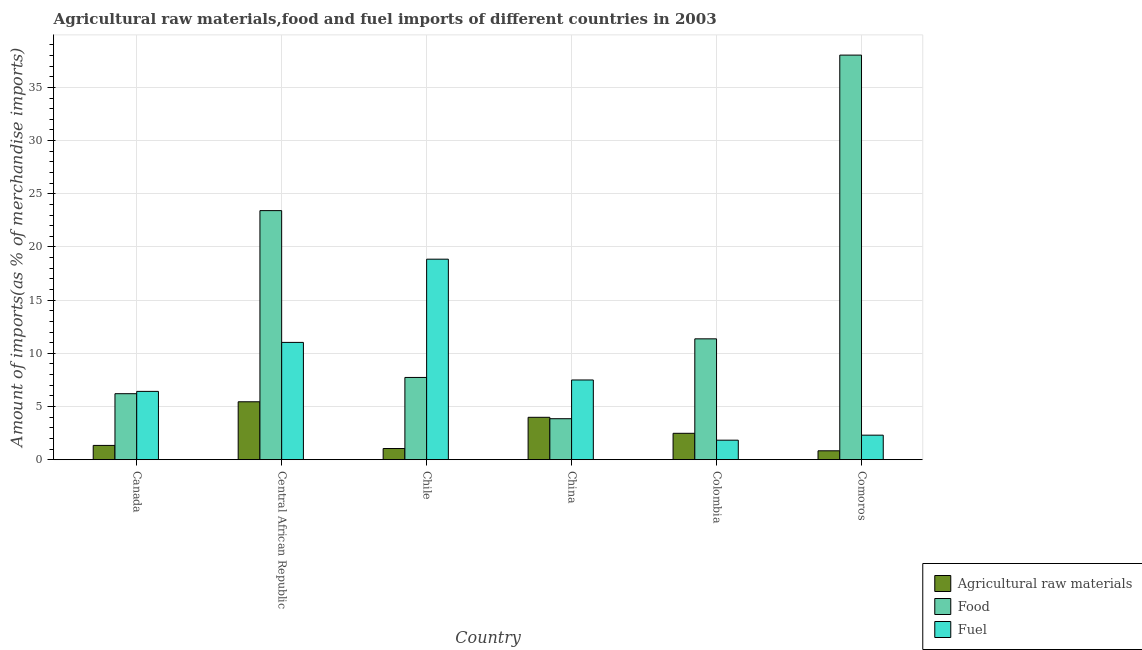How many groups of bars are there?
Your answer should be compact. 6. How many bars are there on the 6th tick from the left?
Your answer should be very brief. 3. How many bars are there on the 2nd tick from the right?
Ensure brevity in your answer.  3. In how many cases, is the number of bars for a given country not equal to the number of legend labels?
Your answer should be very brief. 0. What is the percentage of food imports in China?
Keep it short and to the point. 3.85. Across all countries, what is the maximum percentage of raw materials imports?
Give a very brief answer. 5.45. Across all countries, what is the minimum percentage of raw materials imports?
Provide a short and direct response. 0.84. In which country was the percentage of raw materials imports maximum?
Provide a succinct answer. Central African Republic. In which country was the percentage of fuel imports minimum?
Your response must be concise. Colombia. What is the total percentage of raw materials imports in the graph?
Your answer should be compact. 15.14. What is the difference between the percentage of fuel imports in Central African Republic and that in China?
Keep it short and to the point. 3.53. What is the difference between the percentage of raw materials imports in Chile and the percentage of food imports in Central African Republic?
Provide a short and direct response. -22.37. What is the average percentage of raw materials imports per country?
Your answer should be very brief. 2.52. What is the difference between the percentage of food imports and percentage of raw materials imports in China?
Offer a very short reply. -0.13. In how many countries, is the percentage of raw materials imports greater than 36 %?
Ensure brevity in your answer.  0. What is the ratio of the percentage of raw materials imports in Canada to that in Comoros?
Your response must be concise. 1.61. What is the difference between the highest and the second highest percentage of food imports?
Give a very brief answer. 14.62. What is the difference between the highest and the lowest percentage of food imports?
Your response must be concise. 34.19. In how many countries, is the percentage of raw materials imports greater than the average percentage of raw materials imports taken over all countries?
Make the answer very short. 2. What does the 3rd bar from the left in Colombia represents?
Your response must be concise. Fuel. What does the 1st bar from the right in Central African Republic represents?
Your answer should be very brief. Fuel. Is it the case that in every country, the sum of the percentage of raw materials imports and percentage of food imports is greater than the percentage of fuel imports?
Your response must be concise. No. How many countries are there in the graph?
Your answer should be very brief. 6. Does the graph contain any zero values?
Your response must be concise. No. Where does the legend appear in the graph?
Your answer should be compact. Bottom right. How many legend labels are there?
Offer a very short reply. 3. How are the legend labels stacked?
Your answer should be very brief. Vertical. What is the title of the graph?
Make the answer very short. Agricultural raw materials,food and fuel imports of different countries in 2003. What is the label or title of the Y-axis?
Your response must be concise. Amount of imports(as % of merchandise imports). What is the Amount of imports(as % of merchandise imports) in Agricultural raw materials in Canada?
Provide a short and direct response. 1.34. What is the Amount of imports(as % of merchandise imports) of Food in Canada?
Give a very brief answer. 6.21. What is the Amount of imports(as % of merchandise imports) in Fuel in Canada?
Your response must be concise. 6.42. What is the Amount of imports(as % of merchandise imports) in Agricultural raw materials in Central African Republic?
Your answer should be compact. 5.45. What is the Amount of imports(as % of merchandise imports) in Food in Central African Republic?
Give a very brief answer. 23.42. What is the Amount of imports(as % of merchandise imports) of Fuel in Central African Republic?
Offer a terse response. 11.03. What is the Amount of imports(as % of merchandise imports) of Agricultural raw materials in Chile?
Provide a succinct answer. 1.05. What is the Amount of imports(as % of merchandise imports) of Food in Chile?
Your answer should be very brief. 7.73. What is the Amount of imports(as % of merchandise imports) of Fuel in Chile?
Make the answer very short. 18.85. What is the Amount of imports(as % of merchandise imports) of Agricultural raw materials in China?
Your response must be concise. 3.99. What is the Amount of imports(as % of merchandise imports) in Food in China?
Your response must be concise. 3.85. What is the Amount of imports(as % of merchandise imports) of Fuel in China?
Ensure brevity in your answer.  7.5. What is the Amount of imports(as % of merchandise imports) of Agricultural raw materials in Colombia?
Provide a succinct answer. 2.48. What is the Amount of imports(as % of merchandise imports) of Food in Colombia?
Your response must be concise. 11.36. What is the Amount of imports(as % of merchandise imports) of Fuel in Colombia?
Your answer should be compact. 1.83. What is the Amount of imports(as % of merchandise imports) of Agricultural raw materials in Comoros?
Offer a terse response. 0.84. What is the Amount of imports(as % of merchandise imports) in Food in Comoros?
Your answer should be very brief. 38.04. What is the Amount of imports(as % of merchandise imports) in Fuel in Comoros?
Make the answer very short. 2.31. Across all countries, what is the maximum Amount of imports(as % of merchandise imports) in Agricultural raw materials?
Ensure brevity in your answer.  5.45. Across all countries, what is the maximum Amount of imports(as % of merchandise imports) in Food?
Give a very brief answer. 38.04. Across all countries, what is the maximum Amount of imports(as % of merchandise imports) in Fuel?
Keep it short and to the point. 18.85. Across all countries, what is the minimum Amount of imports(as % of merchandise imports) in Agricultural raw materials?
Give a very brief answer. 0.84. Across all countries, what is the minimum Amount of imports(as % of merchandise imports) in Food?
Make the answer very short. 3.85. Across all countries, what is the minimum Amount of imports(as % of merchandise imports) in Fuel?
Give a very brief answer. 1.83. What is the total Amount of imports(as % of merchandise imports) in Agricultural raw materials in the graph?
Offer a very short reply. 15.14. What is the total Amount of imports(as % of merchandise imports) in Food in the graph?
Provide a succinct answer. 90.62. What is the total Amount of imports(as % of merchandise imports) of Fuel in the graph?
Your answer should be compact. 47.94. What is the difference between the Amount of imports(as % of merchandise imports) of Agricultural raw materials in Canada and that in Central African Republic?
Provide a succinct answer. -4.1. What is the difference between the Amount of imports(as % of merchandise imports) of Food in Canada and that in Central African Republic?
Your answer should be compact. -17.21. What is the difference between the Amount of imports(as % of merchandise imports) in Fuel in Canada and that in Central African Republic?
Your answer should be very brief. -4.61. What is the difference between the Amount of imports(as % of merchandise imports) of Agricultural raw materials in Canada and that in Chile?
Offer a very short reply. 0.29. What is the difference between the Amount of imports(as % of merchandise imports) of Food in Canada and that in Chile?
Give a very brief answer. -1.53. What is the difference between the Amount of imports(as % of merchandise imports) in Fuel in Canada and that in Chile?
Offer a terse response. -12.43. What is the difference between the Amount of imports(as % of merchandise imports) of Agricultural raw materials in Canada and that in China?
Keep it short and to the point. -2.64. What is the difference between the Amount of imports(as % of merchandise imports) of Food in Canada and that in China?
Provide a short and direct response. 2.35. What is the difference between the Amount of imports(as % of merchandise imports) of Fuel in Canada and that in China?
Make the answer very short. -1.07. What is the difference between the Amount of imports(as % of merchandise imports) in Agricultural raw materials in Canada and that in Colombia?
Offer a very short reply. -1.14. What is the difference between the Amount of imports(as % of merchandise imports) of Food in Canada and that in Colombia?
Your answer should be compact. -5.16. What is the difference between the Amount of imports(as % of merchandise imports) in Fuel in Canada and that in Colombia?
Keep it short and to the point. 4.59. What is the difference between the Amount of imports(as % of merchandise imports) of Agricultural raw materials in Canada and that in Comoros?
Keep it short and to the point. 0.51. What is the difference between the Amount of imports(as % of merchandise imports) of Food in Canada and that in Comoros?
Give a very brief answer. -31.83. What is the difference between the Amount of imports(as % of merchandise imports) of Fuel in Canada and that in Comoros?
Your answer should be compact. 4.12. What is the difference between the Amount of imports(as % of merchandise imports) of Agricultural raw materials in Central African Republic and that in Chile?
Offer a very short reply. 4.4. What is the difference between the Amount of imports(as % of merchandise imports) in Food in Central African Republic and that in Chile?
Your response must be concise. 15.69. What is the difference between the Amount of imports(as % of merchandise imports) in Fuel in Central African Republic and that in Chile?
Keep it short and to the point. -7.82. What is the difference between the Amount of imports(as % of merchandise imports) in Agricultural raw materials in Central African Republic and that in China?
Provide a succinct answer. 1.46. What is the difference between the Amount of imports(as % of merchandise imports) of Food in Central African Republic and that in China?
Your response must be concise. 19.56. What is the difference between the Amount of imports(as % of merchandise imports) in Fuel in Central African Republic and that in China?
Offer a terse response. 3.53. What is the difference between the Amount of imports(as % of merchandise imports) in Agricultural raw materials in Central African Republic and that in Colombia?
Your answer should be compact. 2.96. What is the difference between the Amount of imports(as % of merchandise imports) in Food in Central African Republic and that in Colombia?
Your answer should be very brief. 12.06. What is the difference between the Amount of imports(as % of merchandise imports) in Fuel in Central African Republic and that in Colombia?
Make the answer very short. 9.19. What is the difference between the Amount of imports(as % of merchandise imports) of Agricultural raw materials in Central African Republic and that in Comoros?
Offer a terse response. 4.61. What is the difference between the Amount of imports(as % of merchandise imports) in Food in Central African Republic and that in Comoros?
Offer a terse response. -14.62. What is the difference between the Amount of imports(as % of merchandise imports) in Fuel in Central African Republic and that in Comoros?
Make the answer very short. 8.72. What is the difference between the Amount of imports(as % of merchandise imports) in Agricultural raw materials in Chile and that in China?
Give a very brief answer. -2.94. What is the difference between the Amount of imports(as % of merchandise imports) of Food in Chile and that in China?
Offer a terse response. 3.88. What is the difference between the Amount of imports(as % of merchandise imports) of Fuel in Chile and that in China?
Provide a short and direct response. 11.36. What is the difference between the Amount of imports(as % of merchandise imports) of Agricultural raw materials in Chile and that in Colombia?
Ensure brevity in your answer.  -1.43. What is the difference between the Amount of imports(as % of merchandise imports) in Food in Chile and that in Colombia?
Give a very brief answer. -3.63. What is the difference between the Amount of imports(as % of merchandise imports) of Fuel in Chile and that in Colombia?
Provide a succinct answer. 17.02. What is the difference between the Amount of imports(as % of merchandise imports) in Agricultural raw materials in Chile and that in Comoros?
Give a very brief answer. 0.21. What is the difference between the Amount of imports(as % of merchandise imports) in Food in Chile and that in Comoros?
Provide a short and direct response. -30.31. What is the difference between the Amount of imports(as % of merchandise imports) in Fuel in Chile and that in Comoros?
Offer a terse response. 16.55. What is the difference between the Amount of imports(as % of merchandise imports) in Agricultural raw materials in China and that in Colombia?
Your answer should be very brief. 1.5. What is the difference between the Amount of imports(as % of merchandise imports) of Food in China and that in Colombia?
Your response must be concise. -7.51. What is the difference between the Amount of imports(as % of merchandise imports) in Fuel in China and that in Colombia?
Your answer should be compact. 5.66. What is the difference between the Amount of imports(as % of merchandise imports) in Agricultural raw materials in China and that in Comoros?
Your answer should be very brief. 3.15. What is the difference between the Amount of imports(as % of merchandise imports) of Food in China and that in Comoros?
Offer a very short reply. -34.19. What is the difference between the Amount of imports(as % of merchandise imports) in Fuel in China and that in Comoros?
Your response must be concise. 5.19. What is the difference between the Amount of imports(as % of merchandise imports) in Agricultural raw materials in Colombia and that in Comoros?
Offer a very short reply. 1.65. What is the difference between the Amount of imports(as % of merchandise imports) of Food in Colombia and that in Comoros?
Provide a succinct answer. -26.68. What is the difference between the Amount of imports(as % of merchandise imports) in Fuel in Colombia and that in Comoros?
Keep it short and to the point. -0.47. What is the difference between the Amount of imports(as % of merchandise imports) of Agricultural raw materials in Canada and the Amount of imports(as % of merchandise imports) of Food in Central African Republic?
Provide a succinct answer. -22.08. What is the difference between the Amount of imports(as % of merchandise imports) of Agricultural raw materials in Canada and the Amount of imports(as % of merchandise imports) of Fuel in Central African Republic?
Your response must be concise. -9.69. What is the difference between the Amount of imports(as % of merchandise imports) of Food in Canada and the Amount of imports(as % of merchandise imports) of Fuel in Central African Republic?
Keep it short and to the point. -4.82. What is the difference between the Amount of imports(as % of merchandise imports) in Agricultural raw materials in Canada and the Amount of imports(as % of merchandise imports) in Food in Chile?
Make the answer very short. -6.39. What is the difference between the Amount of imports(as % of merchandise imports) of Agricultural raw materials in Canada and the Amount of imports(as % of merchandise imports) of Fuel in Chile?
Make the answer very short. -17.51. What is the difference between the Amount of imports(as % of merchandise imports) of Food in Canada and the Amount of imports(as % of merchandise imports) of Fuel in Chile?
Your answer should be very brief. -12.65. What is the difference between the Amount of imports(as % of merchandise imports) in Agricultural raw materials in Canada and the Amount of imports(as % of merchandise imports) in Food in China?
Keep it short and to the point. -2.51. What is the difference between the Amount of imports(as % of merchandise imports) of Agricultural raw materials in Canada and the Amount of imports(as % of merchandise imports) of Fuel in China?
Provide a short and direct response. -6.15. What is the difference between the Amount of imports(as % of merchandise imports) of Food in Canada and the Amount of imports(as % of merchandise imports) of Fuel in China?
Ensure brevity in your answer.  -1.29. What is the difference between the Amount of imports(as % of merchandise imports) in Agricultural raw materials in Canada and the Amount of imports(as % of merchandise imports) in Food in Colombia?
Offer a very short reply. -10.02. What is the difference between the Amount of imports(as % of merchandise imports) of Agricultural raw materials in Canada and the Amount of imports(as % of merchandise imports) of Fuel in Colombia?
Offer a terse response. -0.49. What is the difference between the Amount of imports(as % of merchandise imports) in Food in Canada and the Amount of imports(as % of merchandise imports) in Fuel in Colombia?
Offer a terse response. 4.37. What is the difference between the Amount of imports(as % of merchandise imports) in Agricultural raw materials in Canada and the Amount of imports(as % of merchandise imports) in Food in Comoros?
Your answer should be very brief. -36.7. What is the difference between the Amount of imports(as % of merchandise imports) in Agricultural raw materials in Canada and the Amount of imports(as % of merchandise imports) in Fuel in Comoros?
Keep it short and to the point. -0.96. What is the difference between the Amount of imports(as % of merchandise imports) in Food in Canada and the Amount of imports(as % of merchandise imports) in Fuel in Comoros?
Your response must be concise. 3.9. What is the difference between the Amount of imports(as % of merchandise imports) of Agricultural raw materials in Central African Republic and the Amount of imports(as % of merchandise imports) of Food in Chile?
Give a very brief answer. -2.29. What is the difference between the Amount of imports(as % of merchandise imports) in Agricultural raw materials in Central African Republic and the Amount of imports(as % of merchandise imports) in Fuel in Chile?
Give a very brief answer. -13.41. What is the difference between the Amount of imports(as % of merchandise imports) in Food in Central African Republic and the Amount of imports(as % of merchandise imports) in Fuel in Chile?
Offer a very short reply. 4.57. What is the difference between the Amount of imports(as % of merchandise imports) of Agricultural raw materials in Central African Republic and the Amount of imports(as % of merchandise imports) of Food in China?
Make the answer very short. 1.59. What is the difference between the Amount of imports(as % of merchandise imports) in Agricultural raw materials in Central African Republic and the Amount of imports(as % of merchandise imports) in Fuel in China?
Make the answer very short. -2.05. What is the difference between the Amount of imports(as % of merchandise imports) in Food in Central African Republic and the Amount of imports(as % of merchandise imports) in Fuel in China?
Provide a short and direct response. 15.92. What is the difference between the Amount of imports(as % of merchandise imports) in Agricultural raw materials in Central African Republic and the Amount of imports(as % of merchandise imports) in Food in Colombia?
Your answer should be compact. -5.92. What is the difference between the Amount of imports(as % of merchandise imports) in Agricultural raw materials in Central African Republic and the Amount of imports(as % of merchandise imports) in Fuel in Colombia?
Ensure brevity in your answer.  3.61. What is the difference between the Amount of imports(as % of merchandise imports) in Food in Central African Republic and the Amount of imports(as % of merchandise imports) in Fuel in Colombia?
Provide a short and direct response. 21.58. What is the difference between the Amount of imports(as % of merchandise imports) in Agricultural raw materials in Central African Republic and the Amount of imports(as % of merchandise imports) in Food in Comoros?
Your answer should be compact. -32.59. What is the difference between the Amount of imports(as % of merchandise imports) in Agricultural raw materials in Central African Republic and the Amount of imports(as % of merchandise imports) in Fuel in Comoros?
Provide a succinct answer. 3.14. What is the difference between the Amount of imports(as % of merchandise imports) of Food in Central African Republic and the Amount of imports(as % of merchandise imports) of Fuel in Comoros?
Offer a very short reply. 21.11. What is the difference between the Amount of imports(as % of merchandise imports) of Agricultural raw materials in Chile and the Amount of imports(as % of merchandise imports) of Food in China?
Offer a very short reply. -2.8. What is the difference between the Amount of imports(as % of merchandise imports) in Agricultural raw materials in Chile and the Amount of imports(as % of merchandise imports) in Fuel in China?
Your answer should be compact. -6.45. What is the difference between the Amount of imports(as % of merchandise imports) of Food in Chile and the Amount of imports(as % of merchandise imports) of Fuel in China?
Your answer should be compact. 0.24. What is the difference between the Amount of imports(as % of merchandise imports) in Agricultural raw materials in Chile and the Amount of imports(as % of merchandise imports) in Food in Colombia?
Give a very brief answer. -10.31. What is the difference between the Amount of imports(as % of merchandise imports) of Agricultural raw materials in Chile and the Amount of imports(as % of merchandise imports) of Fuel in Colombia?
Offer a very short reply. -0.78. What is the difference between the Amount of imports(as % of merchandise imports) of Food in Chile and the Amount of imports(as % of merchandise imports) of Fuel in Colombia?
Ensure brevity in your answer.  5.9. What is the difference between the Amount of imports(as % of merchandise imports) in Agricultural raw materials in Chile and the Amount of imports(as % of merchandise imports) in Food in Comoros?
Provide a succinct answer. -36.99. What is the difference between the Amount of imports(as % of merchandise imports) of Agricultural raw materials in Chile and the Amount of imports(as % of merchandise imports) of Fuel in Comoros?
Provide a succinct answer. -1.26. What is the difference between the Amount of imports(as % of merchandise imports) of Food in Chile and the Amount of imports(as % of merchandise imports) of Fuel in Comoros?
Offer a very short reply. 5.43. What is the difference between the Amount of imports(as % of merchandise imports) in Agricultural raw materials in China and the Amount of imports(as % of merchandise imports) in Food in Colombia?
Your response must be concise. -7.38. What is the difference between the Amount of imports(as % of merchandise imports) in Agricultural raw materials in China and the Amount of imports(as % of merchandise imports) in Fuel in Colombia?
Your answer should be compact. 2.15. What is the difference between the Amount of imports(as % of merchandise imports) of Food in China and the Amount of imports(as % of merchandise imports) of Fuel in Colombia?
Offer a terse response. 2.02. What is the difference between the Amount of imports(as % of merchandise imports) of Agricultural raw materials in China and the Amount of imports(as % of merchandise imports) of Food in Comoros?
Provide a short and direct response. -34.05. What is the difference between the Amount of imports(as % of merchandise imports) in Agricultural raw materials in China and the Amount of imports(as % of merchandise imports) in Fuel in Comoros?
Keep it short and to the point. 1.68. What is the difference between the Amount of imports(as % of merchandise imports) of Food in China and the Amount of imports(as % of merchandise imports) of Fuel in Comoros?
Offer a terse response. 1.55. What is the difference between the Amount of imports(as % of merchandise imports) of Agricultural raw materials in Colombia and the Amount of imports(as % of merchandise imports) of Food in Comoros?
Provide a short and direct response. -35.56. What is the difference between the Amount of imports(as % of merchandise imports) of Agricultural raw materials in Colombia and the Amount of imports(as % of merchandise imports) of Fuel in Comoros?
Give a very brief answer. 0.17. What is the difference between the Amount of imports(as % of merchandise imports) in Food in Colombia and the Amount of imports(as % of merchandise imports) in Fuel in Comoros?
Your response must be concise. 9.06. What is the average Amount of imports(as % of merchandise imports) in Agricultural raw materials per country?
Ensure brevity in your answer.  2.52. What is the average Amount of imports(as % of merchandise imports) in Food per country?
Your answer should be compact. 15.1. What is the average Amount of imports(as % of merchandise imports) in Fuel per country?
Provide a short and direct response. 7.99. What is the difference between the Amount of imports(as % of merchandise imports) of Agricultural raw materials and Amount of imports(as % of merchandise imports) of Food in Canada?
Your response must be concise. -4.86. What is the difference between the Amount of imports(as % of merchandise imports) in Agricultural raw materials and Amount of imports(as % of merchandise imports) in Fuel in Canada?
Give a very brief answer. -5.08. What is the difference between the Amount of imports(as % of merchandise imports) of Food and Amount of imports(as % of merchandise imports) of Fuel in Canada?
Provide a succinct answer. -0.22. What is the difference between the Amount of imports(as % of merchandise imports) of Agricultural raw materials and Amount of imports(as % of merchandise imports) of Food in Central African Republic?
Make the answer very short. -17.97. What is the difference between the Amount of imports(as % of merchandise imports) in Agricultural raw materials and Amount of imports(as % of merchandise imports) in Fuel in Central African Republic?
Offer a terse response. -5.58. What is the difference between the Amount of imports(as % of merchandise imports) of Food and Amount of imports(as % of merchandise imports) of Fuel in Central African Republic?
Provide a short and direct response. 12.39. What is the difference between the Amount of imports(as % of merchandise imports) in Agricultural raw materials and Amount of imports(as % of merchandise imports) in Food in Chile?
Keep it short and to the point. -6.68. What is the difference between the Amount of imports(as % of merchandise imports) in Agricultural raw materials and Amount of imports(as % of merchandise imports) in Fuel in Chile?
Provide a succinct answer. -17.8. What is the difference between the Amount of imports(as % of merchandise imports) of Food and Amount of imports(as % of merchandise imports) of Fuel in Chile?
Your answer should be compact. -11.12. What is the difference between the Amount of imports(as % of merchandise imports) of Agricultural raw materials and Amount of imports(as % of merchandise imports) of Food in China?
Provide a succinct answer. 0.13. What is the difference between the Amount of imports(as % of merchandise imports) in Agricultural raw materials and Amount of imports(as % of merchandise imports) in Fuel in China?
Give a very brief answer. -3.51. What is the difference between the Amount of imports(as % of merchandise imports) of Food and Amount of imports(as % of merchandise imports) of Fuel in China?
Offer a terse response. -3.64. What is the difference between the Amount of imports(as % of merchandise imports) of Agricultural raw materials and Amount of imports(as % of merchandise imports) of Food in Colombia?
Offer a terse response. -8.88. What is the difference between the Amount of imports(as % of merchandise imports) of Agricultural raw materials and Amount of imports(as % of merchandise imports) of Fuel in Colombia?
Your response must be concise. 0.65. What is the difference between the Amount of imports(as % of merchandise imports) of Food and Amount of imports(as % of merchandise imports) of Fuel in Colombia?
Provide a short and direct response. 9.53. What is the difference between the Amount of imports(as % of merchandise imports) in Agricultural raw materials and Amount of imports(as % of merchandise imports) in Food in Comoros?
Provide a succinct answer. -37.2. What is the difference between the Amount of imports(as % of merchandise imports) of Agricultural raw materials and Amount of imports(as % of merchandise imports) of Fuel in Comoros?
Offer a very short reply. -1.47. What is the difference between the Amount of imports(as % of merchandise imports) in Food and Amount of imports(as % of merchandise imports) in Fuel in Comoros?
Your answer should be very brief. 35.73. What is the ratio of the Amount of imports(as % of merchandise imports) in Agricultural raw materials in Canada to that in Central African Republic?
Give a very brief answer. 0.25. What is the ratio of the Amount of imports(as % of merchandise imports) in Food in Canada to that in Central African Republic?
Your answer should be very brief. 0.27. What is the ratio of the Amount of imports(as % of merchandise imports) in Fuel in Canada to that in Central African Republic?
Offer a very short reply. 0.58. What is the ratio of the Amount of imports(as % of merchandise imports) of Agricultural raw materials in Canada to that in Chile?
Keep it short and to the point. 1.28. What is the ratio of the Amount of imports(as % of merchandise imports) in Food in Canada to that in Chile?
Ensure brevity in your answer.  0.8. What is the ratio of the Amount of imports(as % of merchandise imports) in Fuel in Canada to that in Chile?
Your response must be concise. 0.34. What is the ratio of the Amount of imports(as % of merchandise imports) of Agricultural raw materials in Canada to that in China?
Keep it short and to the point. 0.34. What is the ratio of the Amount of imports(as % of merchandise imports) of Food in Canada to that in China?
Make the answer very short. 1.61. What is the ratio of the Amount of imports(as % of merchandise imports) in Fuel in Canada to that in China?
Give a very brief answer. 0.86. What is the ratio of the Amount of imports(as % of merchandise imports) in Agricultural raw materials in Canada to that in Colombia?
Your response must be concise. 0.54. What is the ratio of the Amount of imports(as % of merchandise imports) of Food in Canada to that in Colombia?
Offer a very short reply. 0.55. What is the ratio of the Amount of imports(as % of merchandise imports) of Fuel in Canada to that in Colombia?
Your answer should be very brief. 3.5. What is the ratio of the Amount of imports(as % of merchandise imports) in Agricultural raw materials in Canada to that in Comoros?
Your answer should be very brief. 1.61. What is the ratio of the Amount of imports(as % of merchandise imports) in Food in Canada to that in Comoros?
Provide a succinct answer. 0.16. What is the ratio of the Amount of imports(as % of merchandise imports) in Fuel in Canada to that in Comoros?
Your answer should be compact. 2.78. What is the ratio of the Amount of imports(as % of merchandise imports) in Agricultural raw materials in Central African Republic to that in Chile?
Your answer should be very brief. 5.19. What is the ratio of the Amount of imports(as % of merchandise imports) in Food in Central African Republic to that in Chile?
Make the answer very short. 3.03. What is the ratio of the Amount of imports(as % of merchandise imports) in Fuel in Central African Republic to that in Chile?
Your answer should be compact. 0.58. What is the ratio of the Amount of imports(as % of merchandise imports) of Agricultural raw materials in Central African Republic to that in China?
Give a very brief answer. 1.37. What is the ratio of the Amount of imports(as % of merchandise imports) in Food in Central African Republic to that in China?
Your response must be concise. 6.08. What is the ratio of the Amount of imports(as % of merchandise imports) in Fuel in Central African Republic to that in China?
Your answer should be compact. 1.47. What is the ratio of the Amount of imports(as % of merchandise imports) of Agricultural raw materials in Central African Republic to that in Colombia?
Ensure brevity in your answer.  2.19. What is the ratio of the Amount of imports(as % of merchandise imports) in Food in Central African Republic to that in Colombia?
Ensure brevity in your answer.  2.06. What is the ratio of the Amount of imports(as % of merchandise imports) in Fuel in Central African Republic to that in Colombia?
Give a very brief answer. 6.01. What is the ratio of the Amount of imports(as % of merchandise imports) of Agricultural raw materials in Central African Republic to that in Comoros?
Your answer should be very brief. 6.51. What is the ratio of the Amount of imports(as % of merchandise imports) in Food in Central African Republic to that in Comoros?
Give a very brief answer. 0.62. What is the ratio of the Amount of imports(as % of merchandise imports) in Fuel in Central African Republic to that in Comoros?
Give a very brief answer. 4.78. What is the ratio of the Amount of imports(as % of merchandise imports) in Agricultural raw materials in Chile to that in China?
Provide a short and direct response. 0.26. What is the ratio of the Amount of imports(as % of merchandise imports) of Food in Chile to that in China?
Your response must be concise. 2.01. What is the ratio of the Amount of imports(as % of merchandise imports) of Fuel in Chile to that in China?
Give a very brief answer. 2.52. What is the ratio of the Amount of imports(as % of merchandise imports) in Agricultural raw materials in Chile to that in Colombia?
Your answer should be very brief. 0.42. What is the ratio of the Amount of imports(as % of merchandise imports) of Food in Chile to that in Colombia?
Keep it short and to the point. 0.68. What is the ratio of the Amount of imports(as % of merchandise imports) of Fuel in Chile to that in Colombia?
Keep it short and to the point. 10.28. What is the ratio of the Amount of imports(as % of merchandise imports) of Agricultural raw materials in Chile to that in Comoros?
Offer a very short reply. 1.26. What is the ratio of the Amount of imports(as % of merchandise imports) in Food in Chile to that in Comoros?
Offer a very short reply. 0.2. What is the ratio of the Amount of imports(as % of merchandise imports) of Fuel in Chile to that in Comoros?
Offer a terse response. 8.17. What is the ratio of the Amount of imports(as % of merchandise imports) in Agricultural raw materials in China to that in Colombia?
Provide a succinct answer. 1.61. What is the ratio of the Amount of imports(as % of merchandise imports) in Food in China to that in Colombia?
Ensure brevity in your answer.  0.34. What is the ratio of the Amount of imports(as % of merchandise imports) in Fuel in China to that in Colombia?
Provide a short and direct response. 4.09. What is the ratio of the Amount of imports(as % of merchandise imports) in Agricultural raw materials in China to that in Comoros?
Give a very brief answer. 4.77. What is the ratio of the Amount of imports(as % of merchandise imports) of Food in China to that in Comoros?
Your response must be concise. 0.1. What is the ratio of the Amount of imports(as % of merchandise imports) of Fuel in China to that in Comoros?
Provide a succinct answer. 3.25. What is the ratio of the Amount of imports(as % of merchandise imports) in Agricultural raw materials in Colombia to that in Comoros?
Your response must be concise. 2.97. What is the ratio of the Amount of imports(as % of merchandise imports) of Food in Colombia to that in Comoros?
Provide a short and direct response. 0.3. What is the ratio of the Amount of imports(as % of merchandise imports) in Fuel in Colombia to that in Comoros?
Keep it short and to the point. 0.8. What is the difference between the highest and the second highest Amount of imports(as % of merchandise imports) of Agricultural raw materials?
Provide a short and direct response. 1.46. What is the difference between the highest and the second highest Amount of imports(as % of merchandise imports) of Food?
Ensure brevity in your answer.  14.62. What is the difference between the highest and the second highest Amount of imports(as % of merchandise imports) of Fuel?
Offer a terse response. 7.82. What is the difference between the highest and the lowest Amount of imports(as % of merchandise imports) of Agricultural raw materials?
Keep it short and to the point. 4.61. What is the difference between the highest and the lowest Amount of imports(as % of merchandise imports) of Food?
Your response must be concise. 34.19. What is the difference between the highest and the lowest Amount of imports(as % of merchandise imports) of Fuel?
Provide a short and direct response. 17.02. 